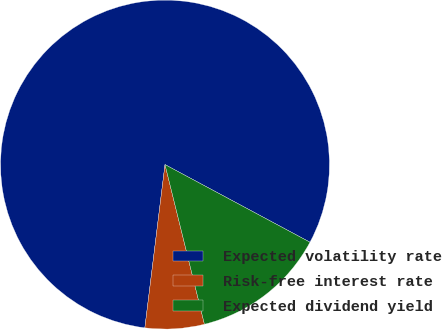Convert chart. <chart><loc_0><loc_0><loc_500><loc_500><pie_chart><fcel>Expected volatility rate<fcel>Risk-free interest rate<fcel>Expected dividend yield<nl><fcel>80.87%<fcel>5.81%<fcel>13.32%<nl></chart> 